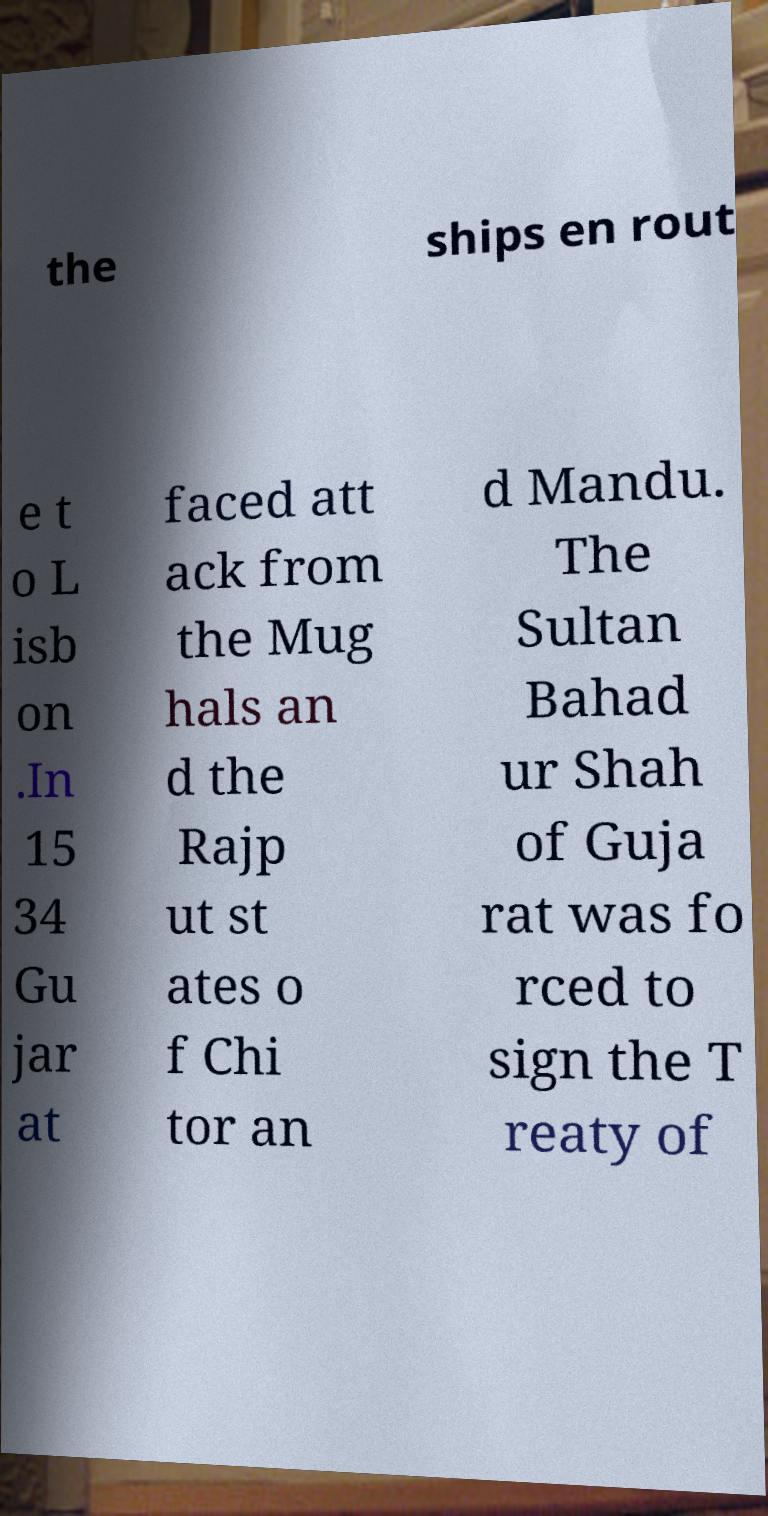Please identify and transcribe the text found in this image. the ships en rout e t o L isb on .In 15 34 Gu jar at faced att ack from the Mug hals an d the Rajp ut st ates o f Chi tor an d Mandu. The Sultan Bahad ur Shah of Guja rat was fo rced to sign the T reaty of 